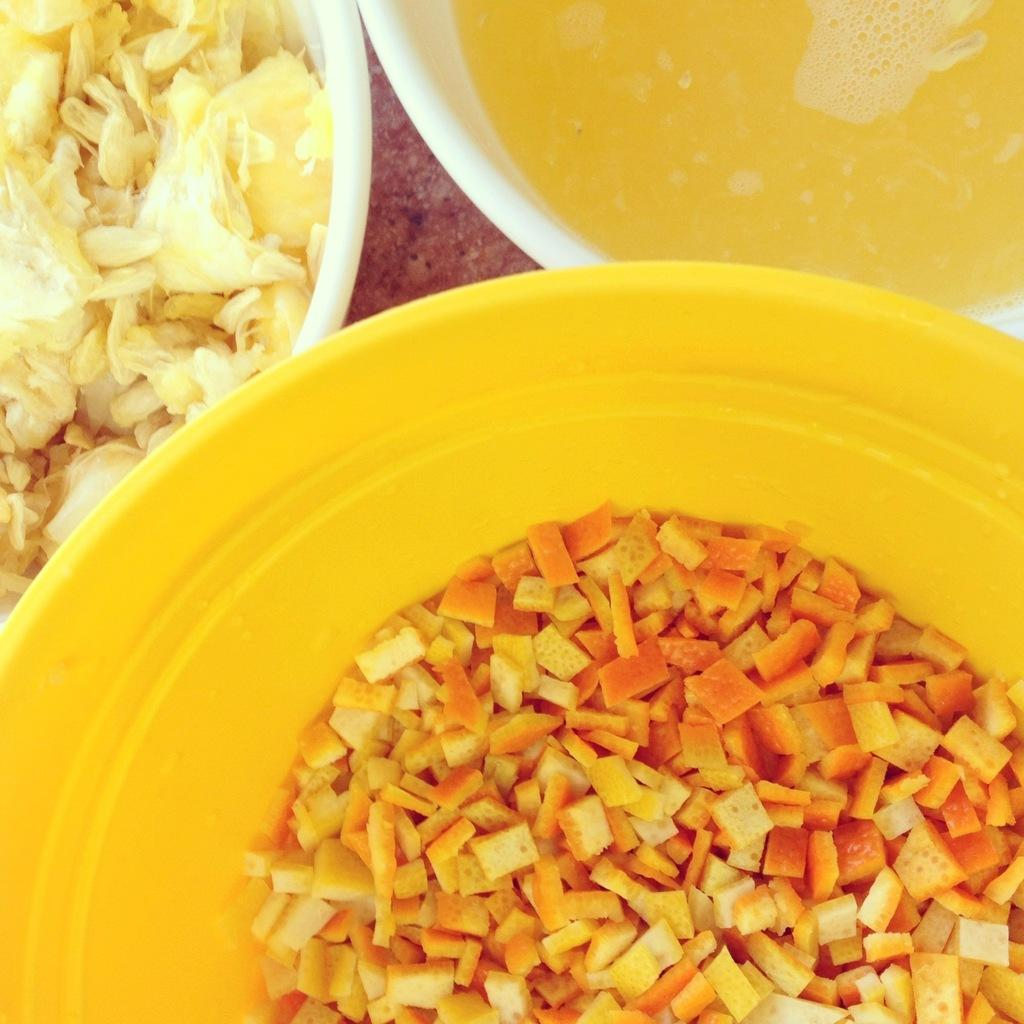What type of food items are present in the image? There are eatables in the image. What beverage is visible in the image? There is a drink in the image. How are the eatables and drink arranged in the image? The eatables and drink are placed in a bowl. How many rabbits can be seen playing with the agreement in the image? There are no rabbits or agreements present in the image. 